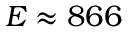Convert formula to latex. <formula><loc_0><loc_0><loc_500><loc_500>E \approx 8 6 6</formula> 